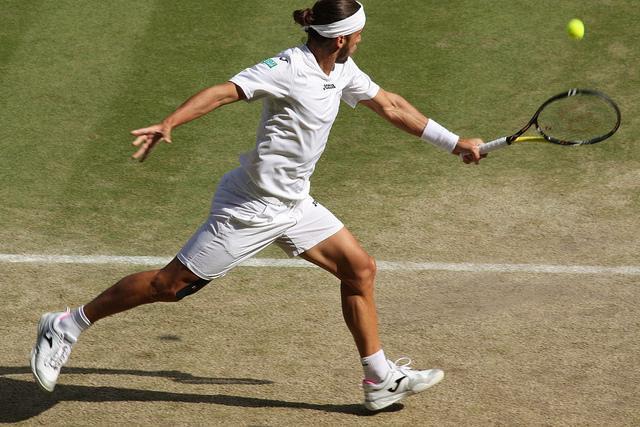How many cows are standing up?
Give a very brief answer. 0. 